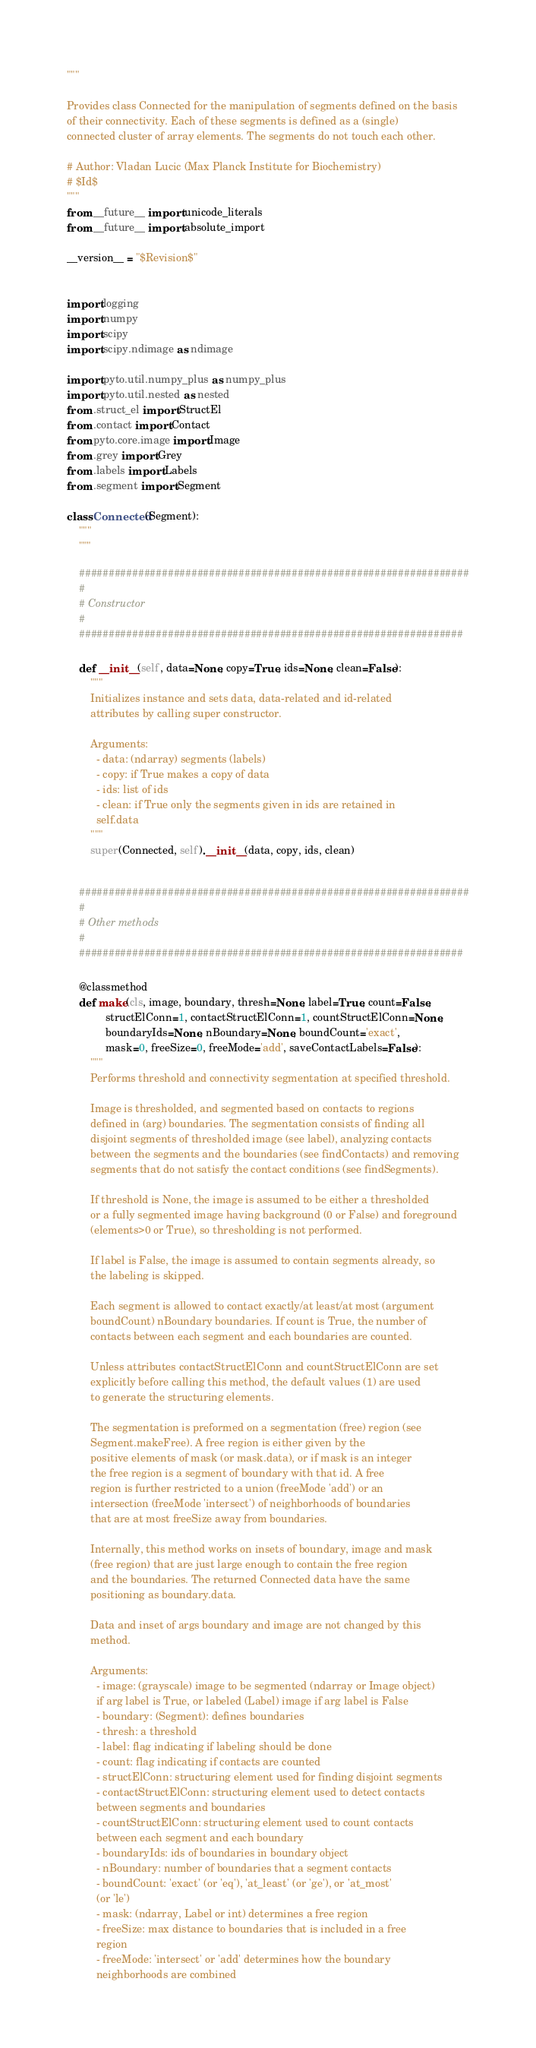<code> <loc_0><loc_0><loc_500><loc_500><_Python_>"""

Provides class Connected for the manipulation of segments defined on the basis
of their connectivity. Each of these segments is defined as a (single)
connected cluster of array elements. The segments do not touch each other.

# Author: Vladan Lucic (Max Planck Institute for Biochemistry)
# $Id$
"""
from __future__ import unicode_literals
from __future__ import absolute_import

__version__ = "$Revision$"


import logging
import numpy
import scipy
import scipy.ndimage as ndimage

import pyto.util.numpy_plus as numpy_plus
import pyto.util.nested as nested
from .struct_el import StructEl
from .contact import Contact
from pyto.core.image import Image
from .grey import Grey
from .labels import Labels
from .segment import Segment

class Connected(Segment):
    """
    """

    ##################################################################
    #
    # Constructor
    #
    #################################################################

    def __init__(self, data=None, copy=True, ids=None, clean=False):
        """
        Initializes instance and sets data, data-related and id-related
        attributes by calling super constructor.  

        Arguments:
          - data: (ndarray) segments (labels)
          - copy: if True makes a copy of data
          - ids: list of ids
          - clean: if True only the segments given in ids are retained in 
          self.data
        """
        super(Connected, self).__init__(data, copy, ids, clean)


    ##################################################################
    #
    # Other methods
    #
    #################################################################

    @classmethod
    def make(cls, image, boundary, thresh=None, label=True, count=False, 
             structElConn=1, contactStructElConn=1, countStructElConn=None,
             boundaryIds=None, nBoundary=None, boundCount='exact',
             mask=0, freeSize=0, freeMode='add', saveContactLabels=False):
        """
        Performs threshold and connectivity segmentation at specified threshold.

        Image is thresholded, and segmented based on contacts to regions
        defined in (arg) boundaries. The segmentation consists of finding all
        disjoint segments of thresholded image (see label), analyzing contacts
        between the segments and the boundaries (see findContacts) and removing
        segments that do not satisfy the contact conditions (see findSegments). 

        If threshold is None, the image is assumed to be either a thresholded
        or a fully segmented image having background (0 or False) and foreground
        (elements>0 or True), so thresholding is not performed.

        If label is False, the image is assumed to contain segments already, so
        the labeling is skipped.

        Each segment is allowed to contact exactly/at least/at most (argument
        boundCount) nBoundary boundaries. If count is True, the number of
        contacts between each segment and each boundaries are counted. 
        
        Unless attributes contactStructElConn and countStructElConn are set
        explicitly before calling this method, the default values (1) are used
        to generate the structuring elements.

        The segmentation is preformed on a segmentation (free) region (see 
        Segment.makeFree). A free region is either given by the 
        positive elements of mask (or mask.data), or if mask is an integer 
        the free region is a segment of boundary with that id. A free 
        region is further restricted to a union (freeMode 'add') or an 
        intersection (freeMode 'intersect') of neighborhoods of boundaries 
        that are at most freeSize away from boundaries. 

        Internally, this method works on insets of boundary, image and mask 
        (free region) that are just large enough to contain the free region 
        and the boundaries. The returned Connected data have the same 
        positioning as boundary.data.

        Data and inset of args boundary and image are not changed by this 
        method. 

        Arguments:
          - image: (grayscale) image to be segmented (ndarray or Image object)
          if arg label is True, or labeled (Label) image if arg label is False
          - boundary: (Segment): defines boundaries
          - thresh: a threshold
          - label: flag indicating if labeling should be done
          - count: flag indicating if contacts are counted
          - structElConn: structuring element used for finding disjoint segments
          - contactStructElConn: structuring element used to detect contacts
          between segments and boundaries
          - countStructElConn: structuring element used to count contacts
          between each segment and each boundary
          - boundaryIds: ids of boundaries in boundary object
          - nBoundary: number of boundaries that a segment contacts 
          - boundCount: 'exact' (or 'eq'), 'at_least' (or 'ge'), or 'at_most'
          (or 'le')
          - mask: (ndarray, Label or int) determines a free region
          - freeSize: max distance to boundaries that is included in a free
          region
          - freeMode: 'intersect' or 'add' determines how the boundary
          neighborhoods are combined</code> 